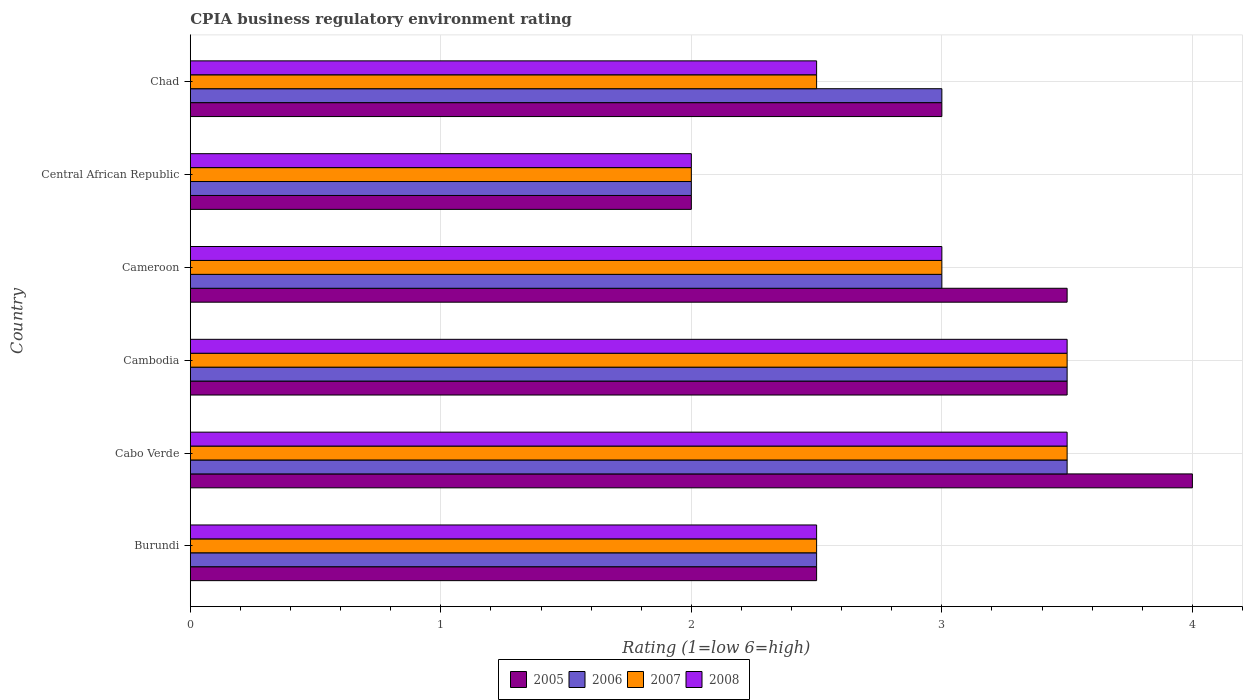How many different coloured bars are there?
Your response must be concise. 4. Are the number of bars per tick equal to the number of legend labels?
Give a very brief answer. Yes. How many bars are there on the 1st tick from the top?
Provide a succinct answer. 4. How many bars are there on the 6th tick from the bottom?
Your response must be concise. 4. What is the label of the 6th group of bars from the top?
Make the answer very short. Burundi. What is the CPIA rating in 2005 in Chad?
Give a very brief answer. 3. In which country was the CPIA rating in 2008 maximum?
Provide a succinct answer. Cabo Verde. In which country was the CPIA rating in 2006 minimum?
Keep it short and to the point. Central African Republic. What is the difference between the CPIA rating in 2008 in Cameroon and that in Chad?
Your answer should be compact. 0.5. What is the difference between the CPIA rating in 2005 in Cambodia and the CPIA rating in 2008 in Central African Republic?
Keep it short and to the point. 1.5. What is the average CPIA rating in 2005 per country?
Make the answer very short. 3.08. What is the ratio of the CPIA rating in 2008 in Burundi to that in Central African Republic?
Offer a very short reply. 1.25. Is the CPIA rating in 2006 in Cameroon less than that in Chad?
Keep it short and to the point. No. Is the difference between the CPIA rating in 2006 in Cabo Verde and Central African Republic greater than the difference between the CPIA rating in 2007 in Cabo Verde and Central African Republic?
Provide a short and direct response. No. What is the difference between the highest and the lowest CPIA rating in 2006?
Give a very brief answer. 1.5. What does the 1st bar from the bottom in Cabo Verde represents?
Keep it short and to the point. 2005. How many legend labels are there?
Keep it short and to the point. 4. What is the title of the graph?
Provide a succinct answer. CPIA business regulatory environment rating. Does "2000" appear as one of the legend labels in the graph?
Offer a very short reply. No. What is the label or title of the X-axis?
Keep it short and to the point. Rating (1=low 6=high). What is the label or title of the Y-axis?
Offer a terse response. Country. What is the Rating (1=low 6=high) in 2005 in Burundi?
Provide a succinct answer. 2.5. What is the Rating (1=low 6=high) of 2006 in Burundi?
Your answer should be compact. 2.5. What is the Rating (1=low 6=high) of 2007 in Burundi?
Your answer should be very brief. 2.5. What is the Rating (1=low 6=high) in 2006 in Cabo Verde?
Offer a terse response. 3.5. What is the Rating (1=low 6=high) of 2007 in Cabo Verde?
Your response must be concise. 3.5. What is the Rating (1=low 6=high) in 2005 in Cambodia?
Keep it short and to the point. 3.5. What is the Rating (1=low 6=high) in 2007 in Cambodia?
Your response must be concise. 3.5. What is the Rating (1=low 6=high) of 2005 in Cameroon?
Your answer should be compact. 3.5. What is the Rating (1=low 6=high) in 2006 in Chad?
Offer a terse response. 3. What is the Rating (1=low 6=high) of 2007 in Chad?
Provide a succinct answer. 2.5. What is the Rating (1=low 6=high) of 2008 in Chad?
Offer a terse response. 2.5. Across all countries, what is the maximum Rating (1=low 6=high) of 2006?
Offer a terse response. 3.5. Across all countries, what is the maximum Rating (1=low 6=high) in 2008?
Your answer should be very brief. 3.5. Across all countries, what is the minimum Rating (1=low 6=high) in 2006?
Your answer should be very brief. 2. Across all countries, what is the minimum Rating (1=low 6=high) of 2007?
Keep it short and to the point. 2. Across all countries, what is the minimum Rating (1=low 6=high) in 2008?
Keep it short and to the point. 2. What is the total Rating (1=low 6=high) in 2005 in the graph?
Provide a succinct answer. 18.5. What is the total Rating (1=low 6=high) of 2006 in the graph?
Give a very brief answer. 17.5. What is the total Rating (1=low 6=high) of 2007 in the graph?
Your response must be concise. 17. What is the difference between the Rating (1=low 6=high) in 2007 in Burundi and that in Cabo Verde?
Your response must be concise. -1. What is the difference between the Rating (1=low 6=high) of 2008 in Burundi and that in Cabo Verde?
Your answer should be very brief. -1. What is the difference between the Rating (1=low 6=high) of 2005 in Burundi and that in Cambodia?
Make the answer very short. -1. What is the difference between the Rating (1=low 6=high) of 2006 in Burundi and that in Cambodia?
Your answer should be very brief. -1. What is the difference between the Rating (1=low 6=high) in 2007 in Burundi and that in Cambodia?
Make the answer very short. -1. What is the difference between the Rating (1=low 6=high) in 2008 in Burundi and that in Cambodia?
Provide a succinct answer. -1. What is the difference between the Rating (1=low 6=high) of 2005 in Burundi and that in Cameroon?
Offer a terse response. -1. What is the difference between the Rating (1=low 6=high) of 2006 in Burundi and that in Cameroon?
Give a very brief answer. -0.5. What is the difference between the Rating (1=low 6=high) in 2007 in Burundi and that in Cameroon?
Ensure brevity in your answer.  -0.5. What is the difference between the Rating (1=low 6=high) of 2005 in Burundi and that in Central African Republic?
Provide a short and direct response. 0.5. What is the difference between the Rating (1=low 6=high) of 2006 in Burundi and that in Central African Republic?
Offer a very short reply. 0.5. What is the difference between the Rating (1=low 6=high) of 2007 in Burundi and that in Central African Republic?
Provide a short and direct response. 0.5. What is the difference between the Rating (1=low 6=high) in 2008 in Burundi and that in Central African Republic?
Provide a short and direct response. 0.5. What is the difference between the Rating (1=low 6=high) of 2006 in Burundi and that in Chad?
Your response must be concise. -0.5. What is the difference between the Rating (1=low 6=high) in 2008 in Burundi and that in Chad?
Offer a terse response. 0. What is the difference between the Rating (1=low 6=high) of 2008 in Cabo Verde and that in Cambodia?
Your answer should be compact. 0. What is the difference between the Rating (1=low 6=high) of 2006 in Cabo Verde and that in Cameroon?
Offer a terse response. 0.5. What is the difference between the Rating (1=low 6=high) of 2008 in Cabo Verde and that in Cameroon?
Your answer should be very brief. 0.5. What is the difference between the Rating (1=low 6=high) in 2005 in Cabo Verde and that in Central African Republic?
Give a very brief answer. 2. What is the difference between the Rating (1=low 6=high) of 2005 in Cabo Verde and that in Chad?
Give a very brief answer. 1. What is the difference between the Rating (1=low 6=high) in 2006 in Cabo Verde and that in Chad?
Ensure brevity in your answer.  0.5. What is the difference between the Rating (1=low 6=high) in 2007 in Cabo Verde and that in Chad?
Your response must be concise. 1. What is the difference between the Rating (1=low 6=high) of 2008 in Cabo Verde and that in Chad?
Offer a terse response. 1. What is the difference between the Rating (1=low 6=high) in 2005 in Cambodia and that in Cameroon?
Offer a terse response. 0. What is the difference between the Rating (1=low 6=high) of 2006 in Cambodia and that in Cameroon?
Make the answer very short. 0.5. What is the difference between the Rating (1=low 6=high) in 2007 in Cambodia and that in Cameroon?
Provide a short and direct response. 0.5. What is the difference between the Rating (1=low 6=high) in 2008 in Cambodia and that in Cameroon?
Ensure brevity in your answer.  0.5. What is the difference between the Rating (1=low 6=high) of 2005 in Cambodia and that in Central African Republic?
Your answer should be compact. 1.5. What is the difference between the Rating (1=low 6=high) of 2006 in Cambodia and that in Central African Republic?
Offer a terse response. 1.5. What is the difference between the Rating (1=low 6=high) in 2008 in Cambodia and that in Central African Republic?
Keep it short and to the point. 1.5. What is the difference between the Rating (1=low 6=high) of 2006 in Cameroon and that in Central African Republic?
Provide a short and direct response. 1. What is the difference between the Rating (1=low 6=high) in 2008 in Cameroon and that in Central African Republic?
Your answer should be very brief. 1. What is the difference between the Rating (1=low 6=high) in 2005 in Cameroon and that in Chad?
Make the answer very short. 0.5. What is the difference between the Rating (1=low 6=high) of 2007 in Cameroon and that in Chad?
Keep it short and to the point. 0.5. What is the difference between the Rating (1=low 6=high) in 2008 in Cameroon and that in Chad?
Offer a terse response. 0.5. What is the difference between the Rating (1=low 6=high) of 2005 in Burundi and the Rating (1=low 6=high) of 2007 in Cabo Verde?
Provide a short and direct response. -1. What is the difference between the Rating (1=low 6=high) of 2005 in Burundi and the Rating (1=low 6=high) of 2008 in Cambodia?
Give a very brief answer. -1. What is the difference between the Rating (1=low 6=high) of 2006 in Burundi and the Rating (1=low 6=high) of 2007 in Cambodia?
Offer a terse response. -1. What is the difference between the Rating (1=low 6=high) in 2006 in Burundi and the Rating (1=low 6=high) in 2008 in Cambodia?
Keep it short and to the point. -1. What is the difference between the Rating (1=low 6=high) of 2007 in Burundi and the Rating (1=low 6=high) of 2008 in Cambodia?
Your answer should be compact. -1. What is the difference between the Rating (1=low 6=high) in 2005 in Burundi and the Rating (1=low 6=high) in 2007 in Cameroon?
Offer a very short reply. -0.5. What is the difference between the Rating (1=low 6=high) in 2005 in Burundi and the Rating (1=low 6=high) in 2006 in Central African Republic?
Offer a very short reply. 0.5. What is the difference between the Rating (1=low 6=high) of 2006 in Burundi and the Rating (1=low 6=high) of 2007 in Central African Republic?
Your answer should be compact. 0.5. What is the difference between the Rating (1=low 6=high) of 2007 in Burundi and the Rating (1=low 6=high) of 2008 in Central African Republic?
Your answer should be very brief. 0.5. What is the difference between the Rating (1=low 6=high) of 2005 in Burundi and the Rating (1=low 6=high) of 2006 in Chad?
Offer a terse response. -0.5. What is the difference between the Rating (1=low 6=high) of 2005 in Burundi and the Rating (1=low 6=high) of 2008 in Chad?
Make the answer very short. 0. What is the difference between the Rating (1=low 6=high) in 2006 in Burundi and the Rating (1=low 6=high) in 2007 in Chad?
Offer a terse response. 0. What is the difference between the Rating (1=low 6=high) of 2007 in Burundi and the Rating (1=low 6=high) of 2008 in Chad?
Give a very brief answer. 0. What is the difference between the Rating (1=low 6=high) in 2005 in Cabo Verde and the Rating (1=low 6=high) in 2006 in Cambodia?
Your response must be concise. 0.5. What is the difference between the Rating (1=low 6=high) in 2005 in Cabo Verde and the Rating (1=low 6=high) in 2007 in Cambodia?
Your answer should be very brief. 0.5. What is the difference between the Rating (1=low 6=high) in 2005 in Cabo Verde and the Rating (1=low 6=high) in 2007 in Cameroon?
Provide a short and direct response. 1. What is the difference between the Rating (1=low 6=high) of 2006 in Cabo Verde and the Rating (1=low 6=high) of 2007 in Cameroon?
Your answer should be compact. 0.5. What is the difference between the Rating (1=low 6=high) in 2005 in Cabo Verde and the Rating (1=low 6=high) in 2006 in Central African Republic?
Make the answer very short. 2. What is the difference between the Rating (1=low 6=high) of 2005 in Cabo Verde and the Rating (1=low 6=high) of 2007 in Central African Republic?
Keep it short and to the point. 2. What is the difference between the Rating (1=low 6=high) in 2005 in Cabo Verde and the Rating (1=low 6=high) in 2008 in Central African Republic?
Provide a short and direct response. 2. What is the difference between the Rating (1=low 6=high) in 2006 in Cabo Verde and the Rating (1=low 6=high) in 2008 in Central African Republic?
Ensure brevity in your answer.  1.5. What is the difference between the Rating (1=low 6=high) in 2005 in Cabo Verde and the Rating (1=low 6=high) in 2006 in Chad?
Provide a short and direct response. 1. What is the difference between the Rating (1=low 6=high) of 2006 in Cabo Verde and the Rating (1=low 6=high) of 2007 in Chad?
Give a very brief answer. 1. What is the difference between the Rating (1=low 6=high) in 2006 in Cabo Verde and the Rating (1=low 6=high) in 2008 in Chad?
Ensure brevity in your answer.  1. What is the difference between the Rating (1=low 6=high) of 2005 in Cambodia and the Rating (1=low 6=high) of 2006 in Cameroon?
Provide a short and direct response. 0.5. What is the difference between the Rating (1=low 6=high) of 2005 in Cambodia and the Rating (1=low 6=high) of 2007 in Cameroon?
Your answer should be compact. 0.5. What is the difference between the Rating (1=low 6=high) in 2005 in Cambodia and the Rating (1=low 6=high) in 2006 in Central African Republic?
Provide a succinct answer. 1.5. What is the difference between the Rating (1=low 6=high) of 2005 in Cambodia and the Rating (1=low 6=high) of 2007 in Central African Republic?
Your response must be concise. 1.5. What is the difference between the Rating (1=low 6=high) of 2005 in Cambodia and the Rating (1=low 6=high) of 2008 in Central African Republic?
Your answer should be compact. 1.5. What is the difference between the Rating (1=low 6=high) in 2006 in Cambodia and the Rating (1=low 6=high) in 2007 in Central African Republic?
Your response must be concise. 1.5. What is the difference between the Rating (1=low 6=high) of 2005 in Cambodia and the Rating (1=low 6=high) of 2006 in Chad?
Provide a succinct answer. 0.5. What is the difference between the Rating (1=low 6=high) in 2006 in Cambodia and the Rating (1=low 6=high) in 2007 in Chad?
Make the answer very short. 1. What is the difference between the Rating (1=low 6=high) of 2007 in Cambodia and the Rating (1=low 6=high) of 2008 in Chad?
Provide a short and direct response. 1. What is the difference between the Rating (1=low 6=high) in 2005 in Cameroon and the Rating (1=low 6=high) in 2006 in Central African Republic?
Offer a very short reply. 1.5. What is the difference between the Rating (1=low 6=high) in 2005 in Cameroon and the Rating (1=low 6=high) in 2008 in Central African Republic?
Your response must be concise. 1.5. What is the difference between the Rating (1=low 6=high) of 2006 in Cameroon and the Rating (1=low 6=high) of 2007 in Central African Republic?
Give a very brief answer. 1. What is the difference between the Rating (1=low 6=high) of 2007 in Cameroon and the Rating (1=low 6=high) of 2008 in Central African Republic?
Your answer should be very brief. 1. What is the difference between the Rating (1=low 6=high) in 2005 in Cameroon and the Rating (1=low 6=high) in 2007 in Chad?
Provide a succinct answer. 1. What is the difference between the Rating (1=low 6=high) in 2005 in Cameroon and the Rating (1=low 6=high) in 2008 in Chad?
Make the answer very short. 1. What is the difference between the Rating (1=low 6=high) in 2006 in Cameroon and the Rating (1=low 6=high) in 2007 in Chad?
Your response must be concise. 0.5. What is the difference between the Rating (1=low 6=high) of 2006 in Cameroon and the Rating (1=low 6=high) of 2008 in Chad?
Make the answer very short. 0.5. What is the difference between the Rating (1=low 6=high) in 2007 in Cameroon and the Rating (1=low 6=high) in 2008 in Chad?
Your answer should be compact. 0.5. What is the difference between the Rating (1=low 6=high) of 2005 in Central African Republic and the Rating (1=low 6=high) of 2006 in Chad?
Your answer should be very brief. -1. What is the difference between the Rating (1=low 6=high) in 2006 in Central African Republic and the Rating (1=low 6=high) in 2007 in Chad?
Provide a short and direct response. -0.5. What is the difference between the Rating (1=low 6=high) of 2007 in Central African Republic and the Rating (1=low 6=high) of 2008 in Chad?
Offer a terse response. -0.5. What is the average Rating (1=low 6=high) of 2005 per country?
Your response must be concise. 3.08. What is the average Rating (1=low 6=high) of 2006 per country?
Ensure brevity in your answer.  2.92. What is the average Rating (1=low 6=high) of 2007 per country?
Your answer should be very brief. 2.83. What is the average Rating (1=low 6=high) of 2008 per country?
Give a very brief answer. 2.83. What is the difference between the Rating (1=low 6=high) of 2005 and Rating (1=low 6=high) of 2008 in Burundi?
Keep it short and to the point. 0. What is the difference between the Rating (1=low 6=high) of 2007 and Rating (1=low 6=high) of 2008 in Burundi?
Provide a succinct answer. 0. What is the difference between the Rating (1=low 6=high) in 2005 and Rating (1=low 6=high) in 2007 in Cabo Verde?
Keep it short and to the point. 0.5. What is the difference between the Rating (1=low 6=high) of 2005 and Rating (1=low 6=high) of 2008 in Cabo Verde?
Provide a short and direct response. 0.5. What is the difference between the Rating (1=low 6=high) in 2006 and Rating (1=low 6=high) in 2007 in Cabo Verde?
Provide a succinct answer. 0. What is the difference between the Rating (1=low 6=high) of 2007 and Rating (1=low 6=high) of 2008 in Cabo Verde?
Offer a very short reply. 0. What is the difference between the Rating (1=low 6=high) in 2005 and Rating (1=low 6=high) in 2006 in Cambodia?
Offer a terse response. 0. What is the difference between the Rating (1=low 6=high) of 2005 and Rating (1=low 6=high) of 2007 in Cambodia?
Provide a succinct answer. 0. What is the difference between the Rating (1=low 6=high) in 2005 and Rating (1=low 6=high) in 2008 in Cambodia?
Give a very brief answer. 0. What is the difference between the Rating (1=low 6=high) of 2006 and Rating (1=low 6=high) of 2007 in Cambodia?
Provide a succinct answer. 0. What is the difference between the Rating (1=low 6=high) in 2006 and Rating (1=low 6=high) in 2008 in Cambodia?
Your answer should be compact. 0. What is the difference between the Rating (1=low 6=high) of 2005 and Rating (1=low 6=high) of 2007 in Cameroon?
Keep it short and to the point. 0.5. What is the difference between the Rating (1=low 6=high) of 2006 and Rating (1=low 6=high) of 2008 in Cameroon?
Your answer should be compact. 0. What is the difference between the Rating (1=low 6=high) in 2007 and Rating (1=low 6=high) in 2008 in Cameroon?
Provide a succinct answer. 0. What is the difference between the Rating (1=low 6=high) of 2005 and Rating (1=low 6=high) of 2006 in Central African Republic?
Keep it short and to the point. 0. What is the difference between the Rating (1=low 6=high) of 2005 and Rating (1=low 6=high) of 2006 in Chad?
Keep it short and to the point. 0. What is the difference between the Rating (1=low 6=high) of 2005 and Rating (1=low 6=high) of 2007 in Chad?
Ensure brevity in your answer.  0.5. What is the difference between the Rating (1=low 6=high) of 2005 and Rating (1=low 6=high) of 2008 in Chad?
Provide a short and direct response. 0.5. What is the difference between the Rating (1=low 6=high) in 2006 and Rating (1=low 6=high) in 2007 in Chad?
Your response must be concise. 0.5. What is the difference between the Rating (1=low 6=high) of 2006 and Rating (1=low 6=high) of 2008 in Chad?
Your answer should be compact. 0.5. What is the difference between the Rating (1=low 6=high) of 2007 and Rating (1=low 6=high) of 2008 in Chad?
Ensure brevity in your answer.  0. What is the ratio of the Rating (1=low 6=high) of 2006 in Burundi to that in Cabo Verde?
Ensure brevity in your answer.  0.71. What is the ratio of the Rating (1=low 6=high) of 2007 in Burundi to that in Cabo Verde?
Make the answer very short. 0.71. What is the ratio of the Rating (1=low 6=high) of 2008 in Burundi to that in Cabo Verde?
Ensure brevity in your answer.  0.71. What is the ratio of the Rating (1=low 6=high) of 2006 in Burundi to that in Cambodia?
Offer a very short reply. 0.71. What is the ratio of the Rating (1=low 6=high) in 2008 in Burundi to that in Cameroon?
Your answer should be compact. 0.83. What is the ratio of the Rating (1=low 6=high) of 2008 in Burundi to that in Central African Republic?
Your answer should be very brief. 1.25. What is the ratio of the Rating (1=low 6=high) of 2005 in Burundi to that in Chad?
Make the answer very short. 0.83. What is the ratio of the Rating (1=low 6=high) of 2008 in Burundi to that in Chad?
Ensure brevity in your answer.  1. What is the ratio of the Rating (1=low 6=high) in 2005 in Cabo Verde to that in Cambodia?
Your response must be concise. 1.14. What is the ratio of the Rating (1=low 6=high) in 2008 in Cabo Verde to that in Cambodia?
Ensure brevity in your answer.  1. What is the ratio of the Rating (1=low 6=high) of 2005 in Cabo Verde to that in Cameroon?
Make the answer very short. 1.14. What is the ratio of the Rating (1=low 6=high) in 2006 in Cabo Verde to that in Cameroon?
Your answer should be very brief. 1.17. What is the ratio of the Rating (1=low 6=high) in 2007 in Cabo Verde to that in Cameroon?
Offer a terse response. 1.17. What is the ratio of the Rating (1=low 6=high) in 2005 in Cabo Verde to that in Central African Republic?
Ensure brevity in your answer.  2. What is the ratio of the Rating (1=low 6=high) in 2007 in Cabo Verde to that in Central African Republic?
Provide a short and direct response. 1.75. What is the ratio of the Rating (1=low 6=high) in 2008 in Cabo Verde to that in Central African Republic?
Keep it short and to the point. 1.75. What is the ratio of the Rating (1=low 6=high) in 2006 in Cabo Verde to that in Chad?
Provide a succinct answer. 1.17. What is the ratio of the Rating (1=low 6=high) in 2008 in Cabo Verde to that in Chad?
Make the answer very short. 1.4. What is the ratio of the Rating (1=low 6=high) of 2006 in Cambodia to that in Cameroon?
Provide a short and direct response. 1.17. What is the ratio of the Rating (1=low 6=high) of 2008 in Cambodia to that in Cameroon?
Give a very brief answer. 1.17. What is the ratio of the Rating (1=low 6=high) of 2005 in Cambodia to that in Central African Republic?
Make the answer very short. 1.75. What is the ratio of the Rating (1=low 6=high) in 2006 in Cambodia to that in Central African Republic?
Your response must be concise. 1.75. What is the ratio of the Rating (1=low 6=high) in 2006 in Cambodia to that in Chad?
Provide a succinct answer. 1.17. What is the ratio of the Rating (1=low 6=high) of 2007 in Cambodia to that in Chad?
Provide a short and direct response. 1.4. What is the ratio of the Rating (1=low 6=high) in 2005 in Cameroon to that in Central African Republic?
Give a very brief answer. 1.75. What is the ratio of the Rating (1=low 6=high) of 2006 in Cameroon to that in Central African Republic?
Ensure brevity in your answer.  1.5. What is the ratio of the Rating (1=low 6=high) in 2007 in Cameroon to that in Central African Republic?
Your answer should be very brief. 1.5. What is the ratio of the Rating (1=low 6=high) in 2008 in Cameroon to that in Central African Republic?
Offer a very short reply. 1.5. What is the ratio of the Rating (1=low 6=high) of 2005 in Cameroon to that in Chad?
Give a very brief answer. 1.17. What is the ratio of the Rating (1=low 6=high) in 2006 in Cameroon to that in Chad?
Your answer should be very brief. 1. What is the ratio of the Rating (1=low 6=high) in 2005 in Central African Republic to that in Chad?
Keep it short and to the point. 0.67. What is the ratio of the Rating (1=low 6=high) of 2006 in Central African Republic to that in Chad?
Ensure brevity in your answer.  0.67. What is the ratio of the Rating (1=low 6=high) in 2007 in Central African Republic to that in Chad?
Provide a succinct answer. 0.8. What is the ratio of the Rating (1=low 6=high) in 2008 in Central African Republic to that in Chad?
Ensure brevity in your answer.  0.8. What is the difference between the highest and the second highest Rating (1=low 6=high) of 2005?
Keep it short and to the point. 0.5. What is the difference between the highest and the second highest Rating (1=low 6=high) of 2006?
Give a very brief answer. 0. What is the difference between the highest and the lowest Rating (1=low 6=high) in 2008?
Give a very brief answer. 1.5. 